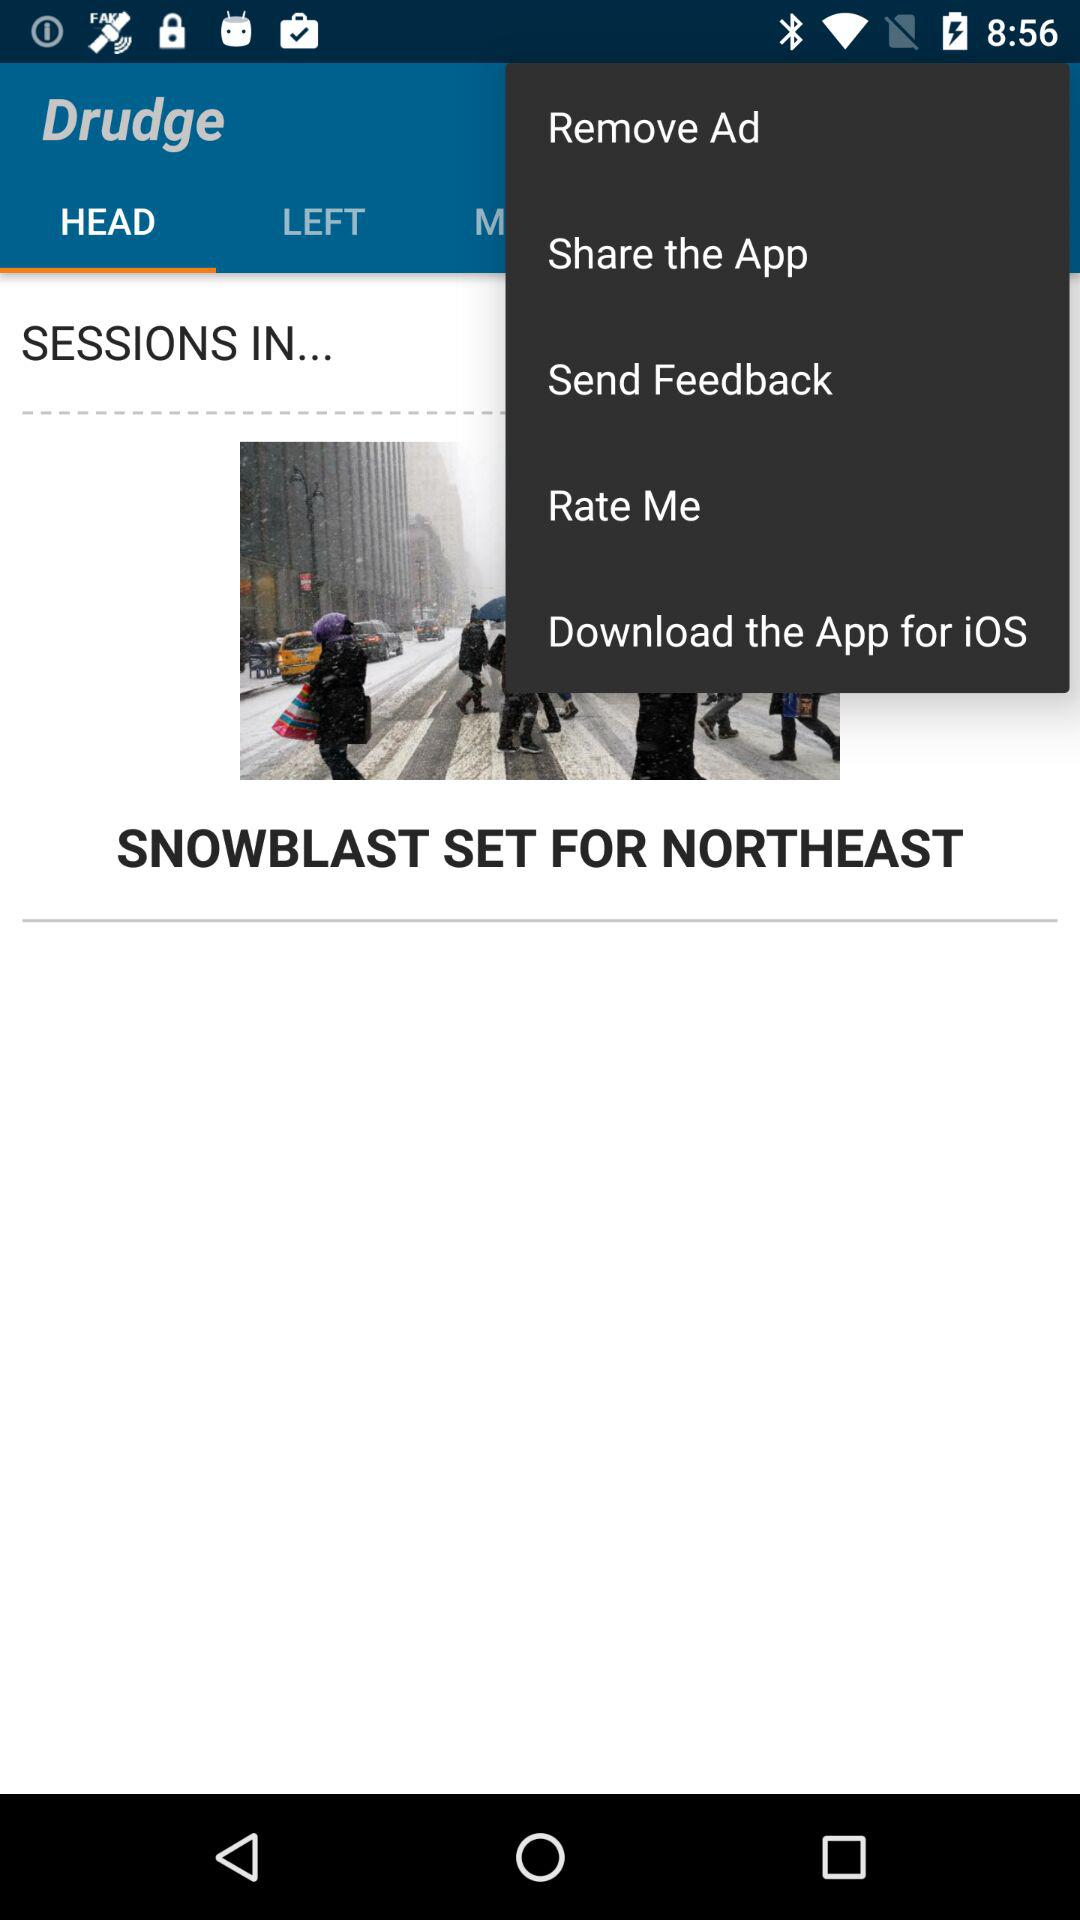Which tab is selected? The selected tab is "HEAD". 